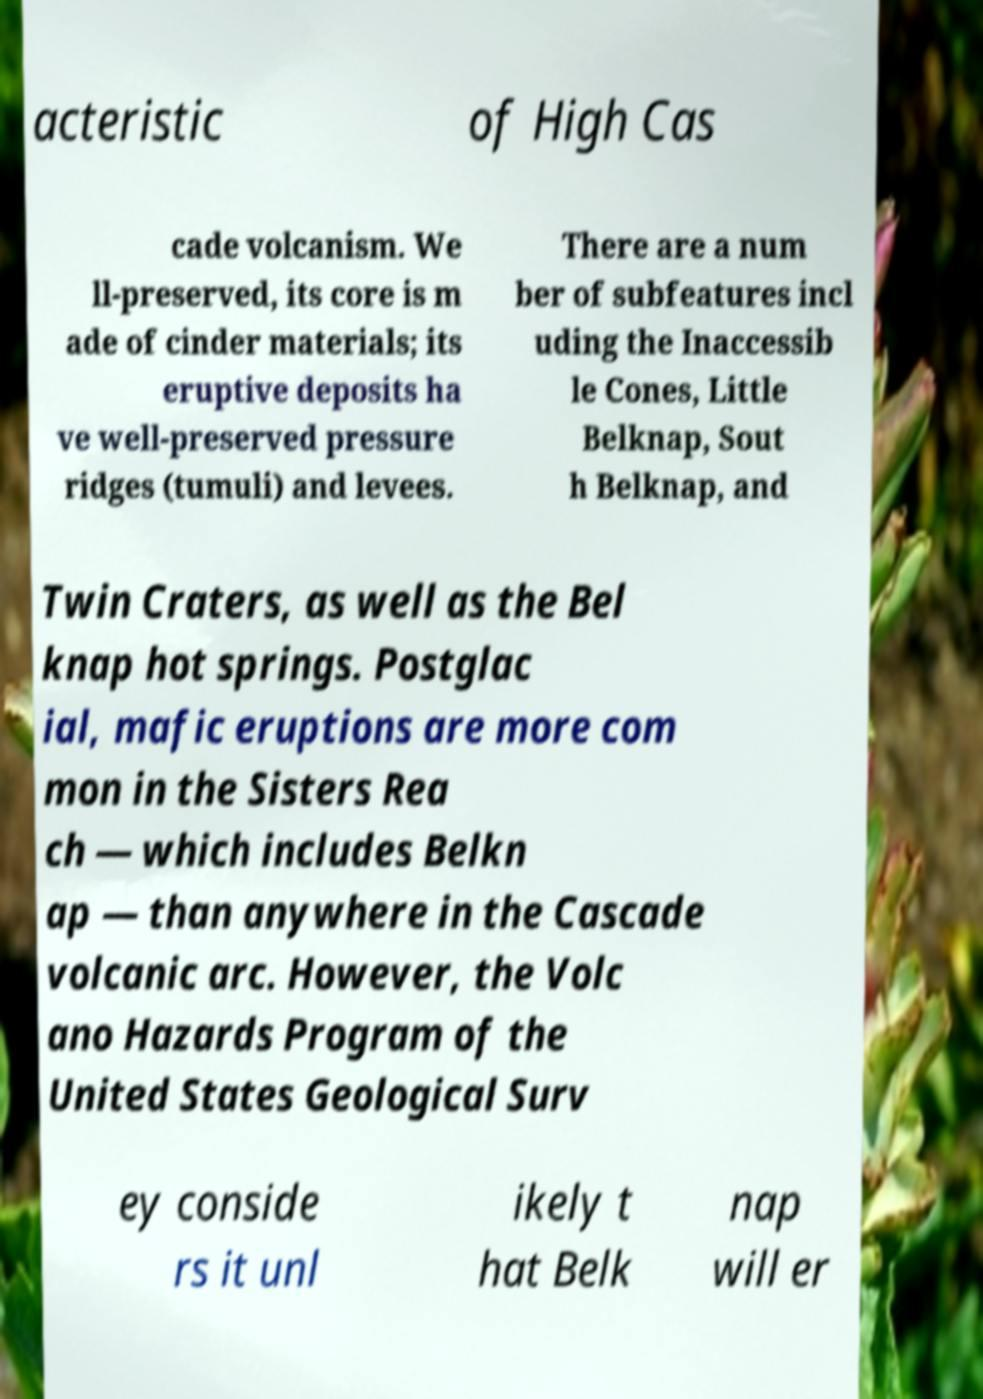There's text embedded in this image that I need extracted. Can you transcribe it verbatim? acteristic of High Cas cade volcanism. We ll-preserved, its core is m ade of cinder materials; its eruptive deposits ha ve well-preserved pressure ridges (tumuli) and levees. There are a num ber of subfeatures incl uding the Inaccessib le Cones, Little Belknap, Sout h Belknap, and Twin Craters, as well as the Bel knap hot springs. Postglac ial, mafic eruptions are more com mon in the Sisters Rea ch — which includes Belkn ap — than anywhere in the Cascade volcanic arc. However, the Volc ano Hazards Program of the United States Geological Surv ey conside rs it unl ikely t hat Belk nap will er 